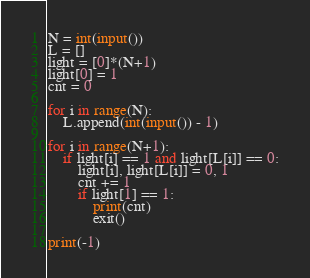<code> <loc_0><loc_0><loc_500><loc_500><_Python_>N = int(input())
L = []
light = [0]*(N+1)
light[0] = 1
cnt = 0

for i in range(N):
    L.append(int(input()) - 1)

for i in range(N+1):
    if light[i] == 1 and light[L[i]] == 0:
        light[i], light[L[i]] = 0, 1
        cnt += 1
        if light[1] == 1:
            print(cnt)
            exit()

print(-1)
</code> 